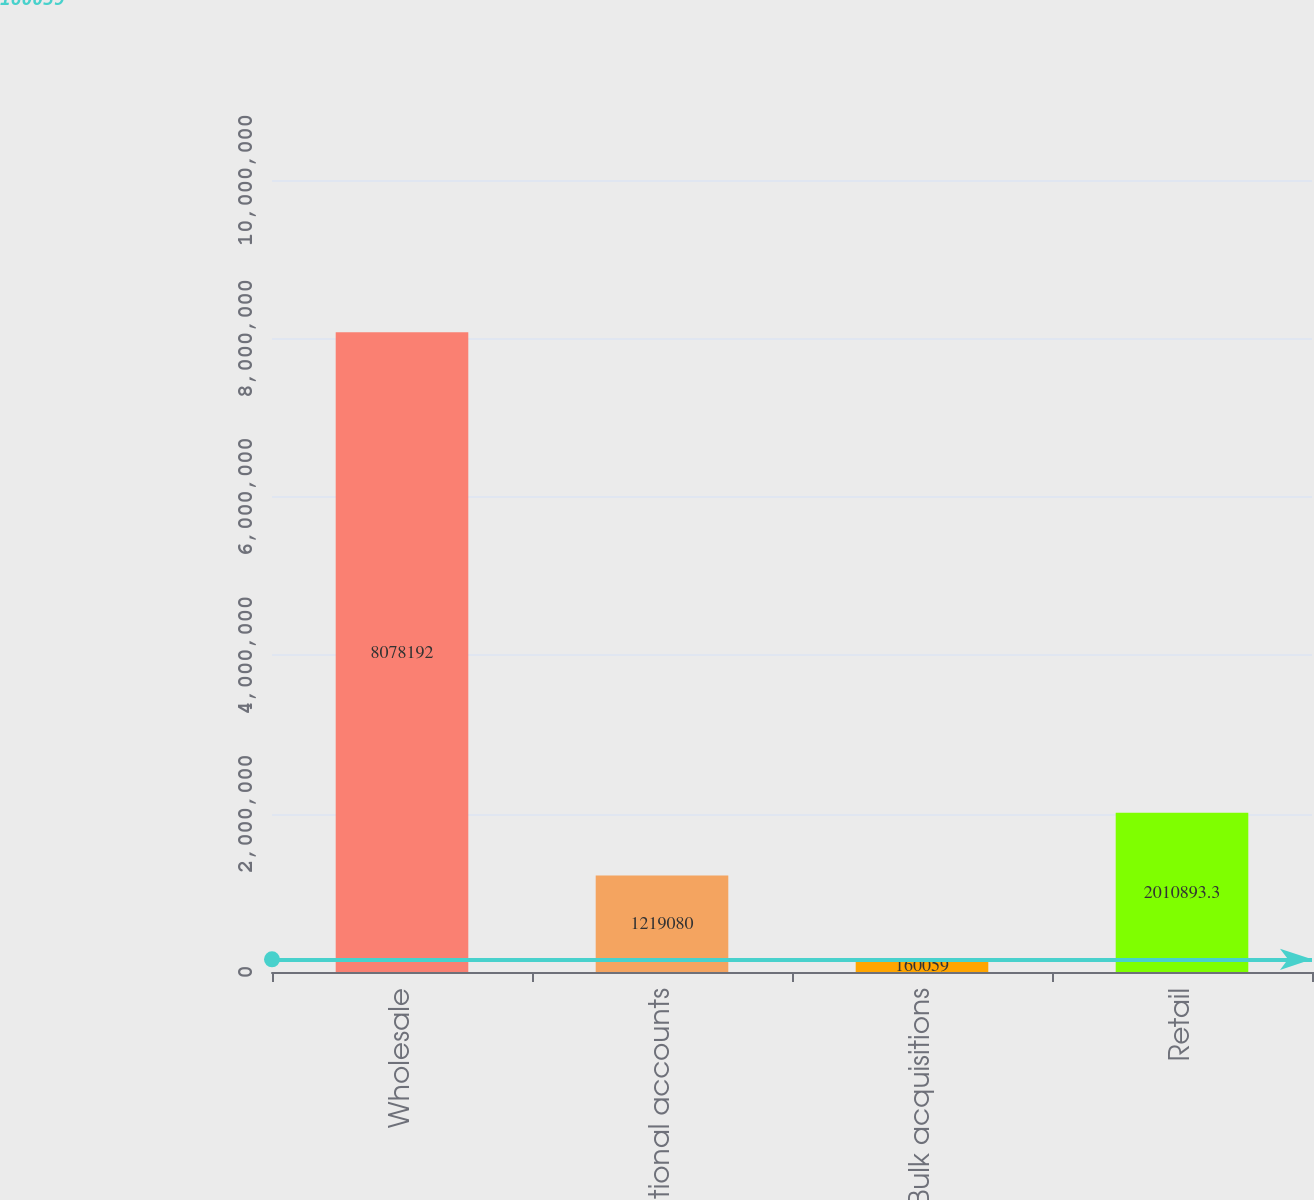<chart> <loc_0><loc_0><loc_500><loc_500><bar_chart><fcel>Wholesale<fcel>National accounts<fcel>Bulk acquisitions<fcel>Retail<nl><fcel>8.07819e+06<fcel>1.21908e+06<fcel>160059<fcel>2.01089e+06<nl></chart> 